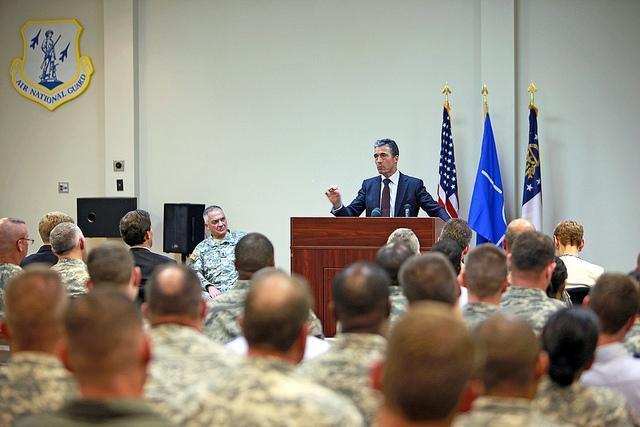How many flags are there?
Give a very brief answer. 3. How many people are there?
Give a very brief answer. 12. 